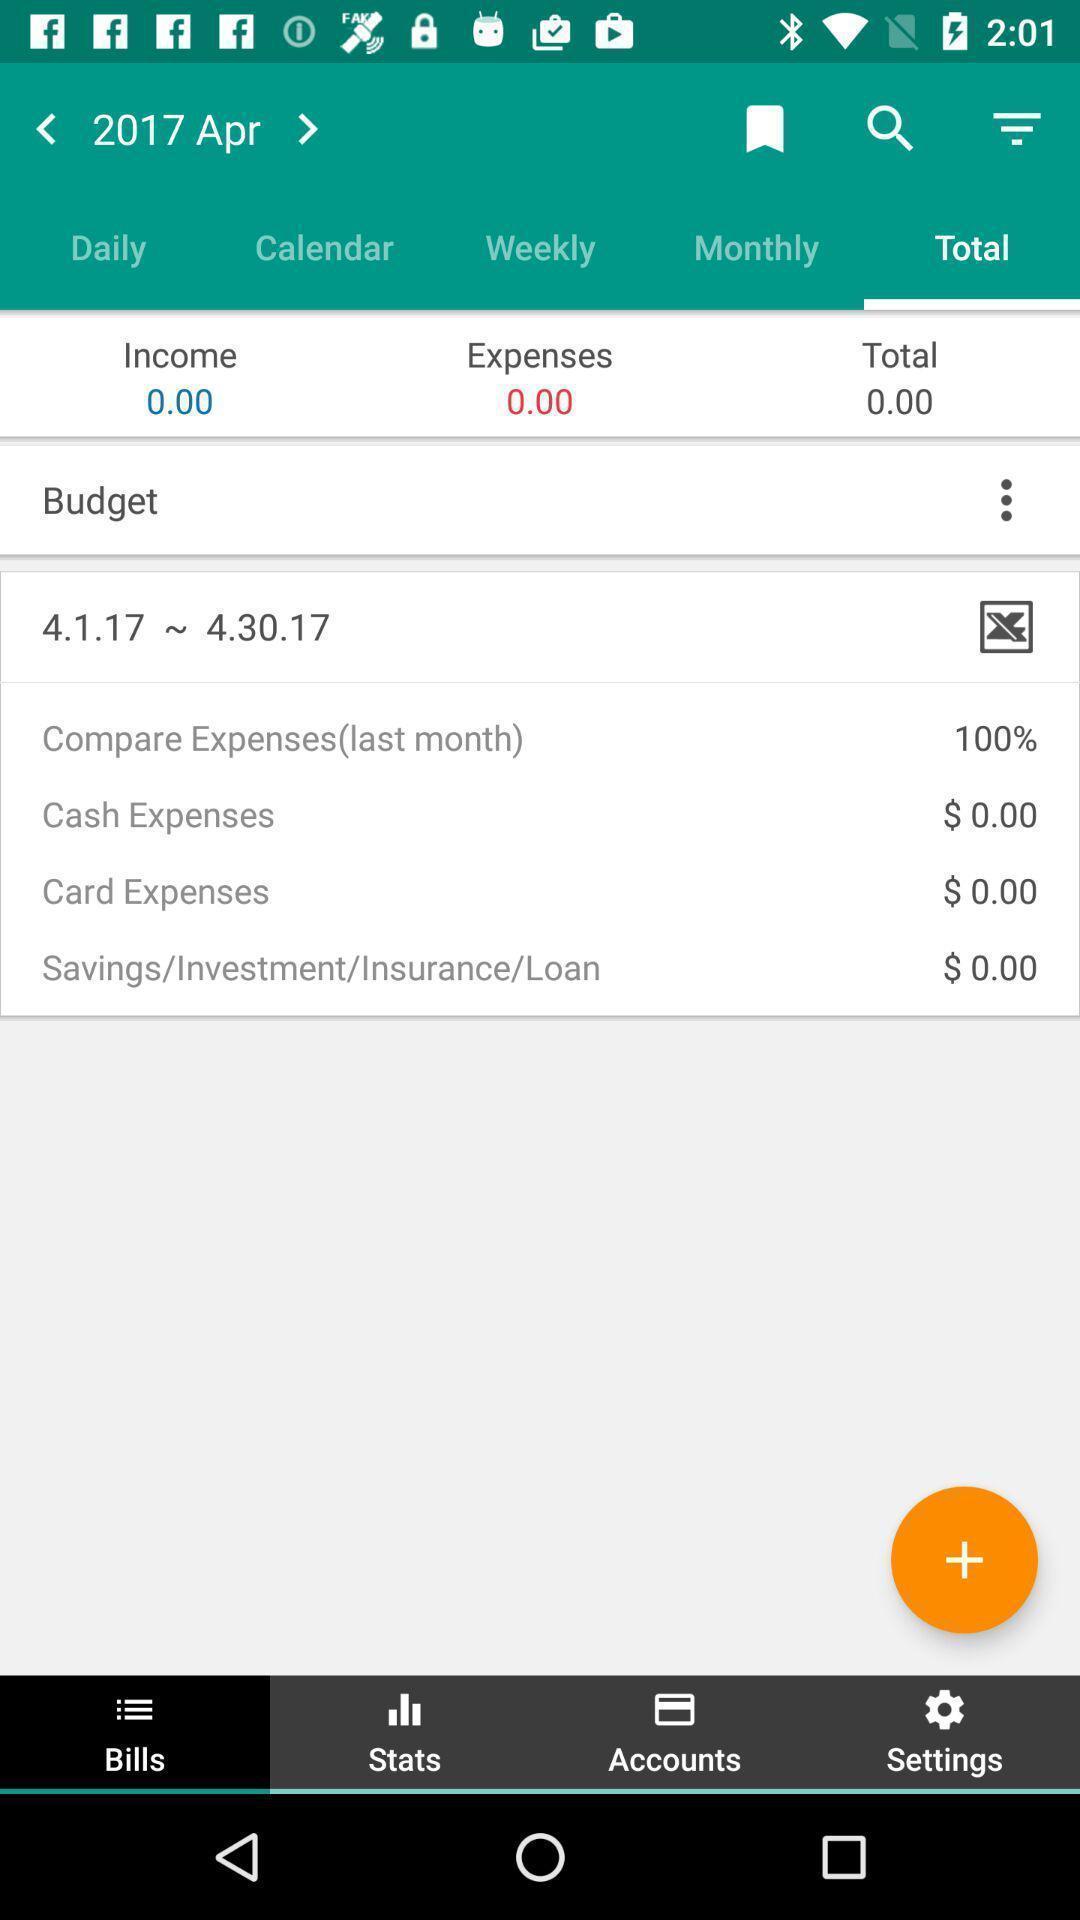Describe the content in this image. Screen showing total page with budget in expenses tracker app. 